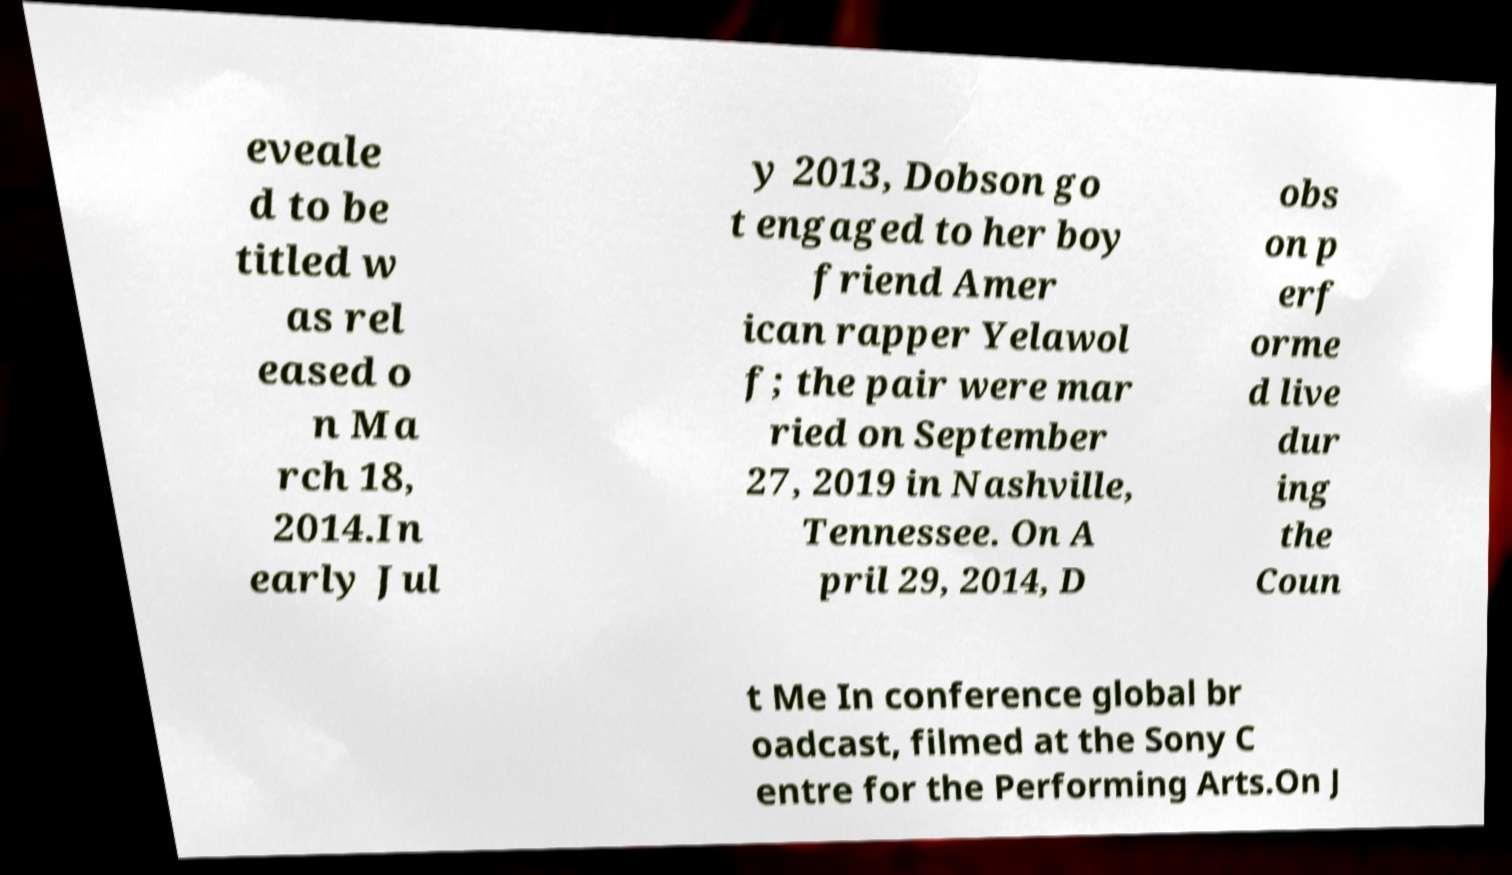For documentation purposes, I need the text within this image transcribed. Could you provide that? eveale d to be titled w as rel eased o n Ma rch 18, 2014.In early Jul y 2013, Dobson go t engaged to her boy friend Amer ican rapper Yelawol f; the pair were mar ried on September 27, 2019 in Nashville, Tennessee. On A pril 29, 2014, D obs on p erf orme d live dur ing the Coun t Me In conference global br oadcast, filmed at the Sony C entre for the Performing Arts.On J 